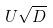<formula> <loc_0><loc_0><loc_500><loc_500>U \sqrt { D }</formula> 